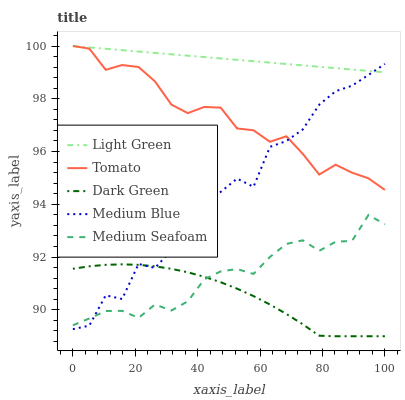Does Dark Green have the minimum area under the curve?
Answer yes or no. Yes. Does Light Green have the maximum area under the curve?
Answer yes or no. Yes. Does Medium Blue have the minimum area under the curve?
Answer yes or no. No. Does Medium Blue have the maximum area under the curve?
Answer yes or no. No. Is Light Green the smoothest?
Answer yes or no. Yes. Is Medium Blue the roughest?
Answer yes or no. Yes. Is Medium Seafoam the smoothest?
Answer yes or no. No. Is Medium Seafoam the roughest?
Answer yes or no. No. Does Dark Green have the lowest value?
Answer yes or no. Yes. Does Medium Blue have the lowest value?
Answer yes or no. No. Does Light Green have the highest value?
Answer yes or no. Yes. Does Medium Blue have the highest value?
Answer yes or no. No. Is Medium Seafoam less than Light Green?
Answer yes or no. Yes. Is Tomato greater than Dark Green?
Answer yes or no. Yes. Does Medium Blue intersect Dark Green?
Answer yes or no. Yes. Is Medium Blue less than Dark Green?
Answer yes or no. No. Is Medium Blue greater than Dark Green?
Answer yes or no. No. Does Medium Seafoam intersect Light Green?
Answer yes or no. No. 